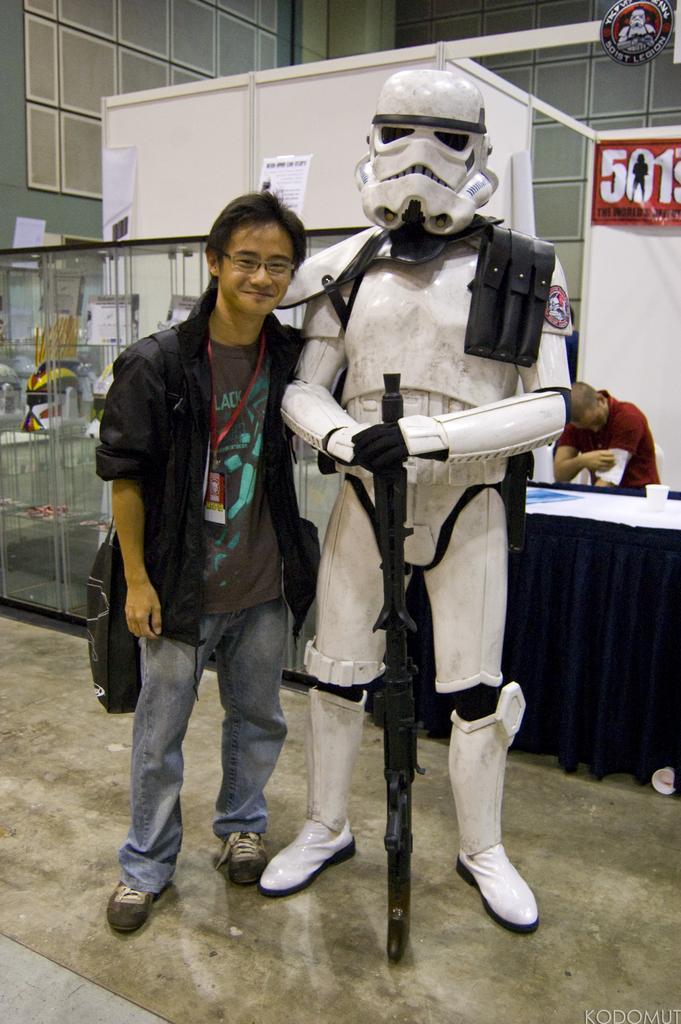How would you summarize this image in a sentence or two? In this image we can see a person and beside the person it looks like a statue and there is a table covered with cloth, a person holding an object, there is a banner and few posts attached to board and there is a glass object and a wall in the background. 